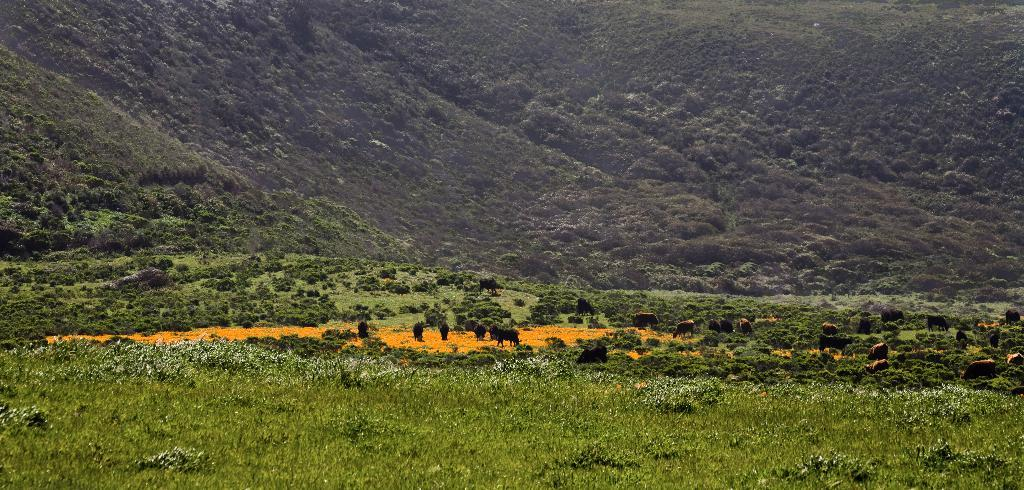What type of animals can be seen in the image? There are animals in the image. What are the animals doing in the image? The animals are grazing on a field. What can be seen in the background of the image? There are mountains and trees in the background of the image. How does the stem of the tree change color in the image? There is no stem of a tree present in the image, as the trees are in the background and not the main focus. 